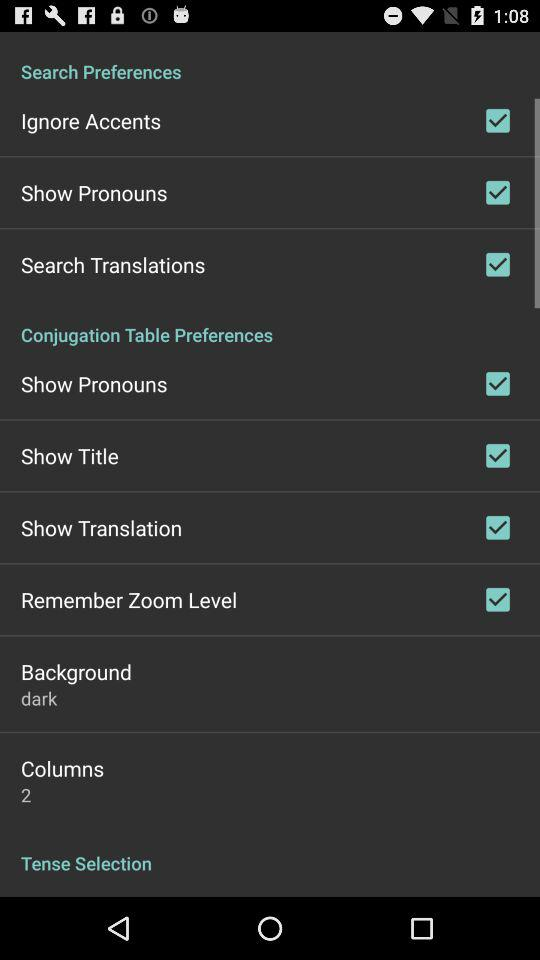How many checkboxes are in the search preferences section?
Answer the question using a single word or phrase. 3 